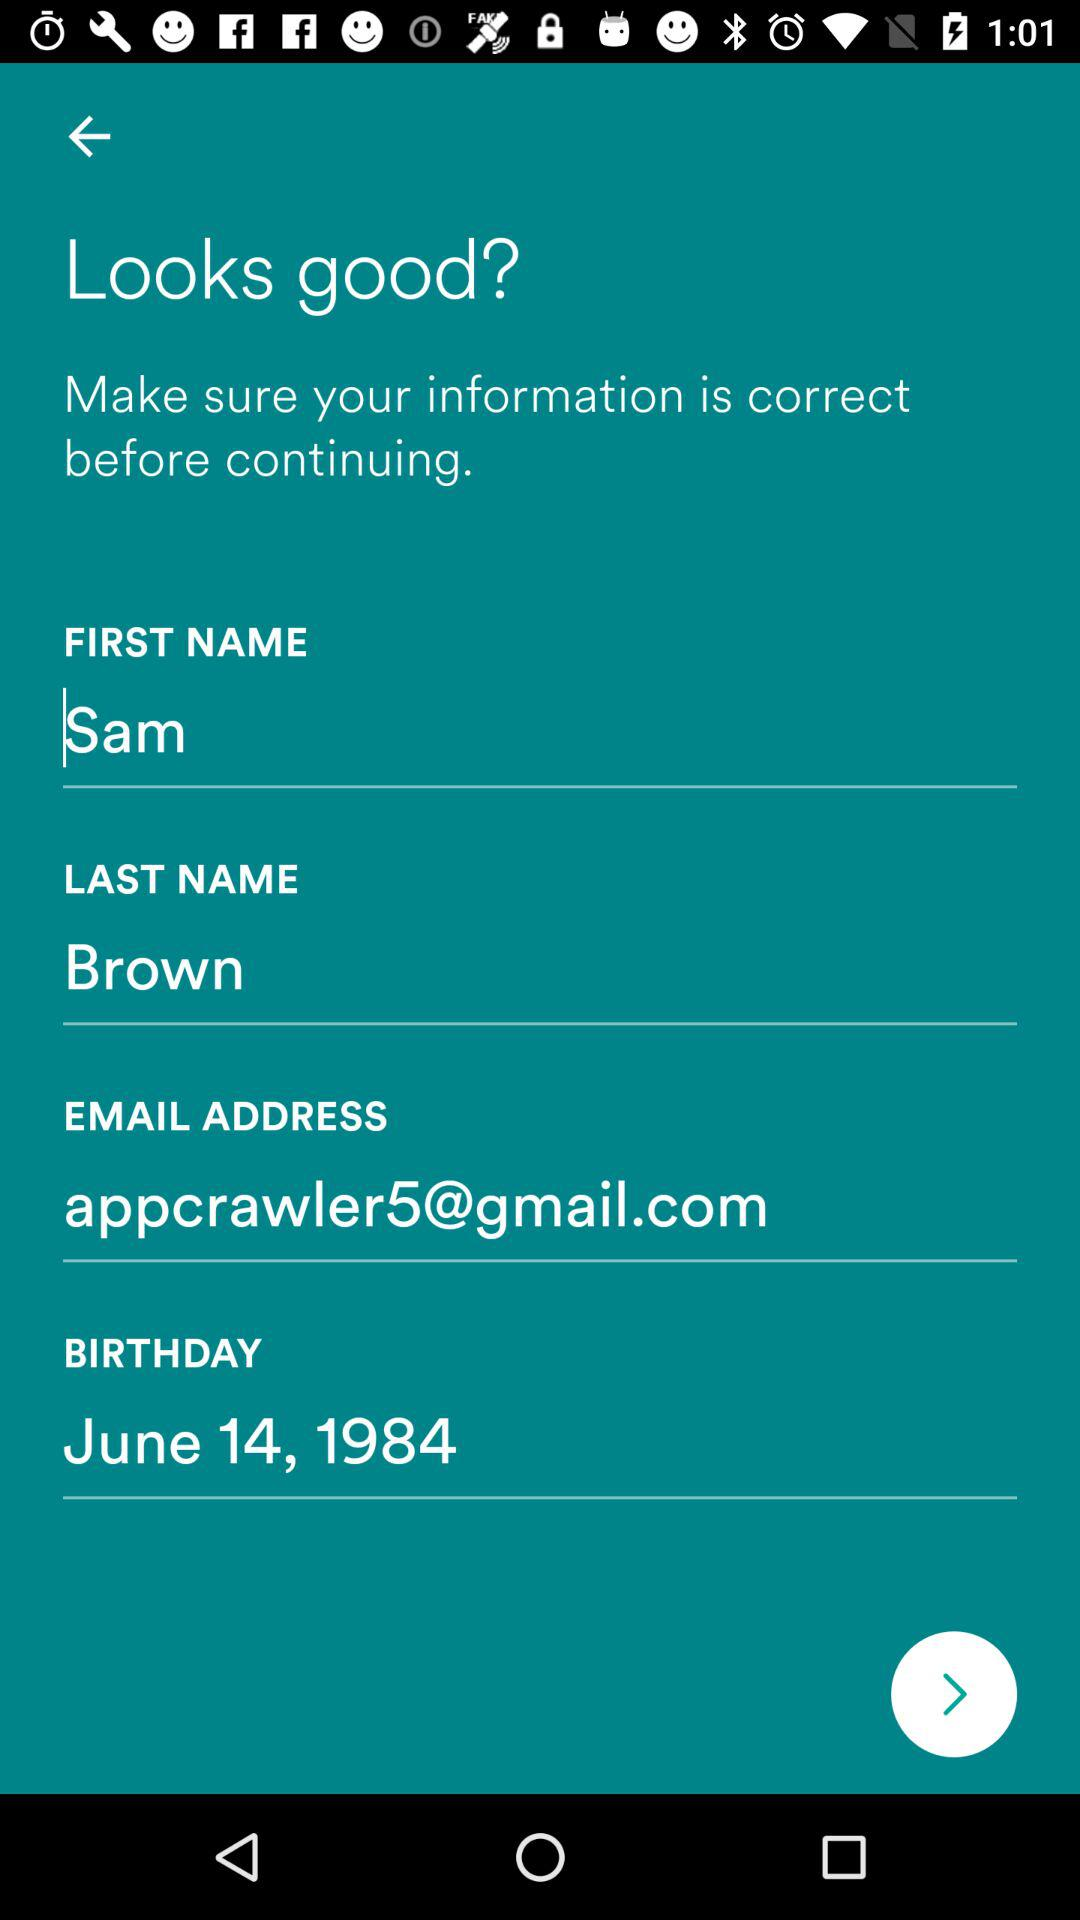What is the email ID of Sam? The email ID is appcrawler5@gmail.com. 